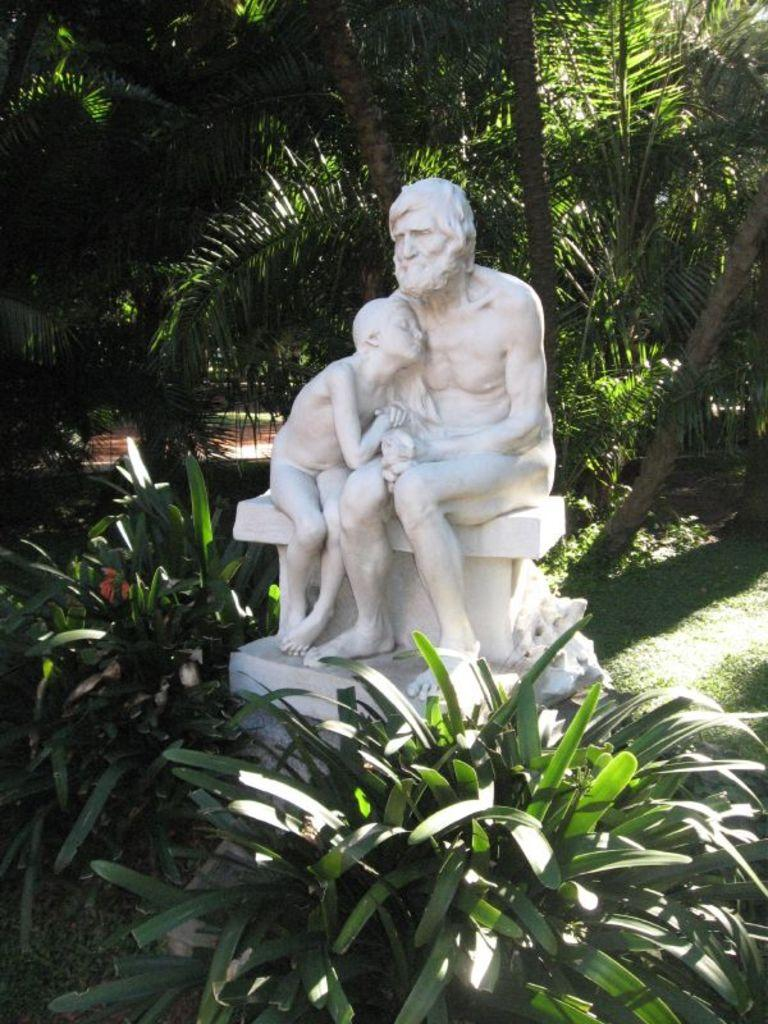What is the main subject of the image? There is a statue of a man in the image. Where is the statue located? The statue is sitting on a wall. What can be seen in the background of the image? There are trees in the background of the image. Are there any plants near the statue? Yes, there are plants near the statue at the bottom of the image. What type of pancake is being served at the business in the image? There is no business or pancake present in the image; it features a statue of a man sitting on a wall with plants nearby. 